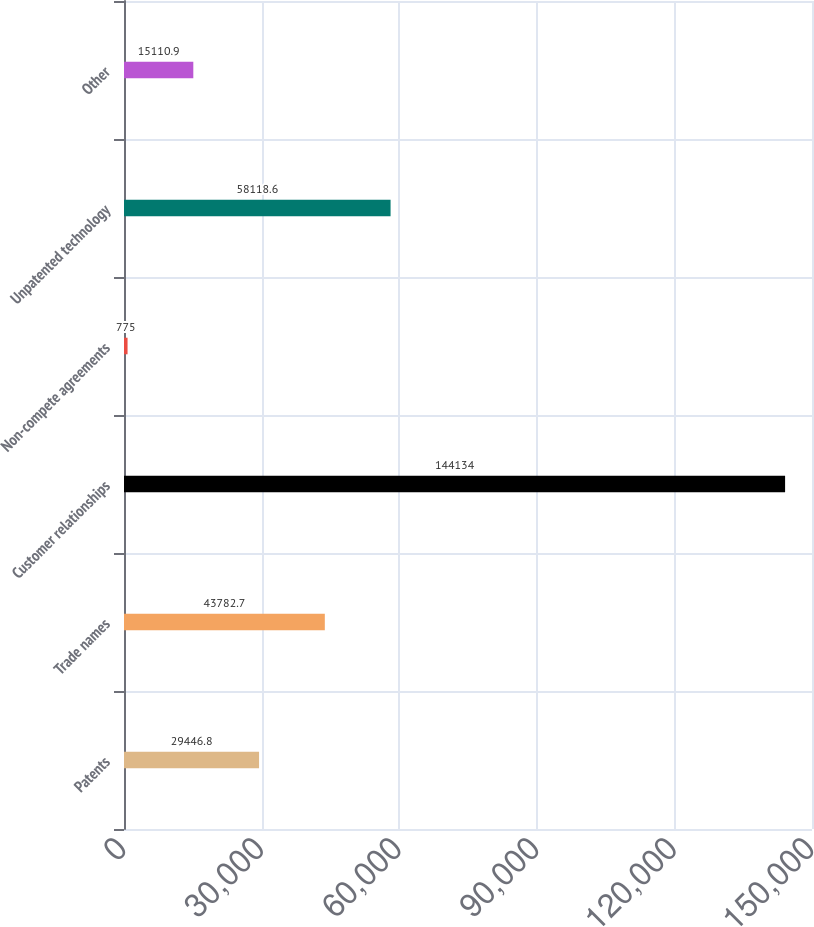Convert chart to OTSL. <chart><loc_0><loc_0><loc_500><loc_500><bar_chart><fcel>Patents<fcel>Trade names<fcel>Customer relationships<fcel>Non-compete agreements<fcel>Unpatented technology<fcel>Other<nl><fcel>29446.8<fcel>43782.7<fcel>144134<fcel>775<fcel>58118.6<fcel>15110.9<nl></chart> 